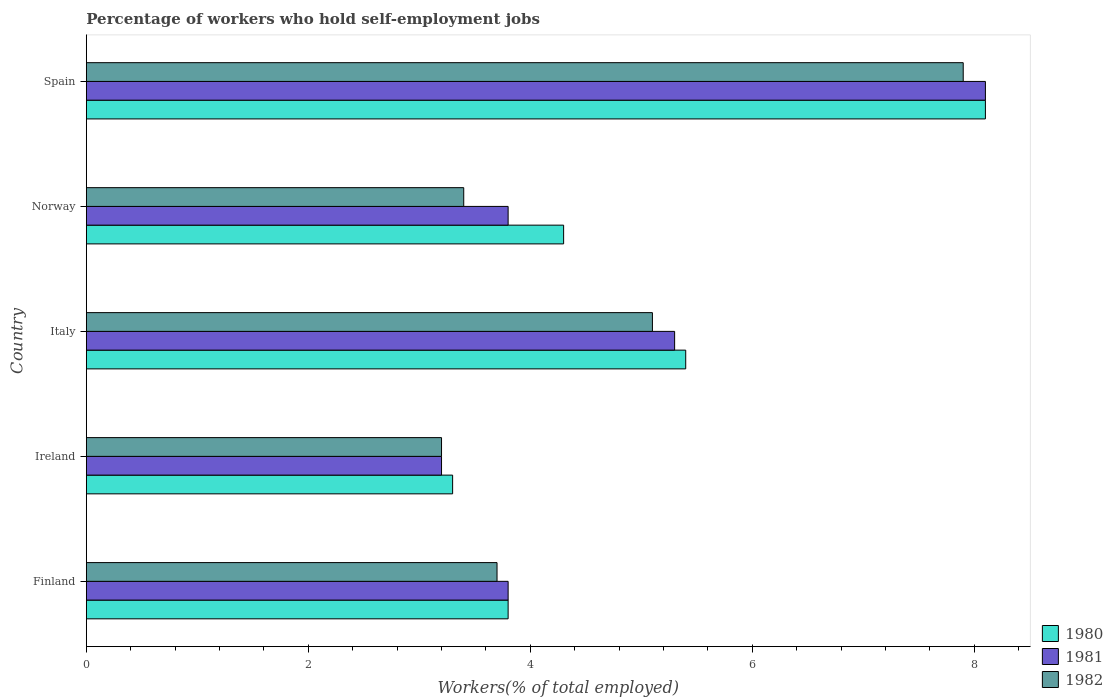How many bars are there on the 2nd tick from the top?
Offer a very short reply. 3. How many bars are there on the 3rd tick from the bottom?
Your response must be concise. 3. What is the label of the 4th group of bars from the top?
Your answer should be very brief. Ireland. In how many cases, is the number of bars for a given country not equal to the number of legend labels?
Your answer should be compact. 0. What is the percentage of self-employed workers in 1981 in Finland?
Ensure brevity in your answer.  3.8. Across all countries, what is the maximum percentage of self-employed workers in 1980?
Your answer should be compact. 8.1. Across all countries, what is the minimum percentage of self-employed workers in 1980?
Make the answer very short. 3.3. In which country was the percentage of self-employed workers in 1981 minimum?
Offer a terse response. Ireland. What is the total percentage of self-employed workers in 1982 in the graph?
Make the answer very short. 23.3. What is the difference between the percentage of self-employed workers in 1980 in Ireland and that in Italy?
Your answer should be compact. -2.1. What is the difference between the percentage of self-employed workers in 1981 in Italy and the percentage of self-employed workers in 1980 in Finland?
Ensure brevity in your answer.  1.5. What is the average percentage of self-employed workers in 1982 per country?
Give a very brief answer. 4.66. What is the difference between the percentage of self-employed workers in 1982 and percentage of self-employed workers in 1980 in Finland?
Your answer should be compact. -0.1. What is the ratio of the percentage of self-employed workers in 1981 in Finland to that in Spain?
Give a very brief answer. 0.47. Is the percentage of self-employed workers in 1982 in Ireland less than that in Norway?
Your answer should be very brief. Yes. What is the difference between the highest and the second highest percentage of self-employed workers in 1982?
Provide a short and direct response. 2.8. What is the difference between the highest and the lowest percentage of self-employed workers in 1981?
Give a very brief answer. 4.9. Is the sum of the percentage of self-employed workers in 1980 in Finland and Italy greater than the maximum percentage of self-employed workers in 1982 across all countries?
Your answer should be very brief. Yes. Is it the case that in every country, the sum of the percentage of self-employed workers in 1980 and percentage of self-employed workers in 1981 is greater than the percentage of self-employed workers in 1982?
Your answer should be compact. Yes. How many bars are there?
Ensure brevity in your answer.  15. Are all the bars in the graph horizontal?
Ensure brevity in your answer.  Yes. What is the difference between two consecutive major ticks on the X-axis?
Provide a succinct answer. 2. Are the values on the major ticks of X-axis written in scientific E-notation?
Provide a succinct answer. No. Does the graph contain grids?
Your answer should be compact. No. Where does the legend appear in the graph?
Make the answer very short. Bottom right. How many legend labels are there?
Make the answer very short. 3. How are the legend labels stacked?
Your response must be concise. Vertical. What is the title of the graph?
Offer a very short reply. Percentage of workers who hold self-employment jobs. What is the label or title of the X-axis?
Offer a terse response. Workers(% of total employed). What is the Workers(% of total employed) in 1980 in Finland?
Make the answer very short. 3.8. What is the Workers(% of total employed) in 1981 in Finland?
Offer a terse response. 3.8. What is the Workers(% of total employed) of 1982 in Finland?
Ensure brevity in your answer.  3.7. What is the Workers(% of total employed) in 1980 in Ireland?
Offer a very short reply. 3.3. What is the Workers(% of total employed) in 1981 in Ireland?
Your response must be concise. 3.2. What is the Workers(% of total employed) in 1982 in Ireland?
Provide a succinct answer. 3.2. What is the Workers(% of total employed) of 1980 in Italy?
Your response must be concise. 5.4. What is the Workers(% of total employed) in 1981 in Italy?
Provide a short and direct response. 5.3. What is the Workers(% of total employed) in 1982 in Italy?
Your response must be concise. 5.1. What is the Workers(% of total employed) of 1980 in Norway?
Provide a succinct answer. 4.3. What is the Workers(% of total employed) in 1981 in Norway?
Keep it short and to the point. 3.8. What is the Workers(% of total employed) of 1982 in Norway?
Provide a succinct answer. 3.4. What is the Workers(% of total employed) in 1980 in Spain?
Your answer should be very brief. 8.1. What is the Workers(% of total employed) in 1981 in Spain?
Provide a succinct answer. 8.1. What is the Workers(% of total employed) of 1982 in Spain?
Give a very brief answer. 7.9. Across all countries, what is the maximum Workers(% of total employed) in 1980?
Make the answer very short. 8.1. Across all countries, what is the maximum Workers(% of total employed) of 1981?
Make the answer very short. 8.1. Across all countries, what is the maximum Workers(% of total employed) of 1982?
Offer a terse response. 7.9. Across all countries, what is the minimum Workers(% of total employed) in 1980?
Offer a very short reply. 3.3. Across all countries, what is the minimum Workers(% of total employed) in 1981?
Offer a terse response. 3.2. Across all countries, what is the minimum Workers(% of total employed) of 1982?
Provide a short and direct response. 3.2. What is the total Workers(% of total employed) of 1980 in the graph?
Your answer should be compact. 24.9. What is the total Workers(% of total employed) of 1981 in the graph?
Keep it short and to the point. 24.2. What is the total Workers(% of total employed) in 1982 in the graph?
Provide a succinct answer. 23.3. What is the difference between the Workers(% of total employed) in 1980 in Finland and that in Italy?
Your answer should be very brief. -1.6. What is the difference between the Workers(% of total employed) of 1982 in Finland and that in Italy?
Your answer should be compact. -1.4. What is the difference between the Workers(% of total employed) of 1980 in Finland and that in Norway?
Provide a short and direct response. -0.5. What is the difference between the Workers(% of total employed) in 1981 in Finland and that in Norway?
Make the answer very short. 0. What is the difference between the Workers(% of total employed) of 1980 in Ireland and that in Italy?
Offer a very short reply. -2.1. What is the difference between the Workers(% of total employed) of 1981 in Ireland and that in Italy?
Offer a terse response. -2.1. What is the difference between the Workers(% of total employed) of 1980 in Ireland and that in Norway?
Your answer should be compact. -1. What is the difference between the Workers(% of total employed) in 1980 in Ireland and that in Spain?
Your answer should be compact. -4.8. What is the difference between the Workers(% of total employed) of 1981 in Ireland and that in Spain?
Give a very brief answer. -4.9. What is the difference between the Workers(% of total employed) of 1980 in Italy and that in Norway?
Keep it short and to the point. 1.1. What is the difference between the Workers(% of total employed) in 1981 in Italy and that in Norway?
Offer a terse response. 1.5. What is the difference between the Workers(% of total employed) in 1980 in Italy and that in Spain?
Offer a very short reply. -2.7. What is the difference between the Workers(% of total employed) in 1981 in Italy and that in Spain?
Ensure brevity in your answer.  -2.8. What is the difference between the Workers(% of total employed) in 1982 in Italy and that in Spain?
Keep it short and to the point. -2.8. What is the difference between the Workers(% of total employed) of 1982 in Norway and that in Spain?
Your response must be concise. -4.5. What is the difference between the Workers(% of total employed) of 1981 in Finland and the Workers(% of total employed) of 1982 in Ireland?
Your answer should be very brief. 0.6. What is the difference between the Workers(% of total employed) in 1980 in Finland and the Workers(% of total employed) in 1981 in Italy?
Keep it short and to the point. -1.5. What is the difference between the Workers(% of total employed) of 1981 in Finland and the Workers(% of total employed) of 1982 in Italy?
Keep it short and to the point. -1.3. What is the difference between the Workers(% of total employed) in 1980 in Finland and the Workers(% of total employed) in 1981 in Norway?
Ensure brevity in your answer.  0. What is the difference between the Workers(% of total employed) in 1980 in Finland and the Workers(% of total employed) in 1982 in Norway?
Your answer should be very brief. 0.4. What is the difference between the Workers(% of total employed) of 1981 in Finland and the Workers(% of total employed) of 1982 in Norway?
Keep it short and to the point. 0.4. What is the difference between the Workers(% of total employed) in 1980 in Finland and the Workers(% of total employed) in 1981 in Spain?
Offer a terse response. -4.3. What is the difference between the Workers(% of total employed) in 1981 in Ireland and the Workers(% of total employed) in 1982 in Italy?
Offer a terse response. -1.9. What is the difference between the Workers(% of total employed) in 1980 in Ireland and the Workers(% of total employed) in 1982 in Spain?
Your response must be concise. -4.6. What is the difference between the Workers(% of total employed) in 1981 in Ireland and the Workers(% of total employed) in 1982 in Spain?
Make the answer very short. -4.7. What is the difference between the Workers(% of total employed) of 1980 in Italy and the Workers(% of total employed) of 1981 in Norway?
Your answer should be very brief. 1.6. What is the difference between the Workers(% of total employed) of 1980 in Italy and the Workers(% of total employed) of 1982 in Norway?
Your answer should be very brief. 2. What is the difference between the Workers(% of total employed) of 1981 in Italy and the Workers(% of total employed) of 1982 in Spain?
Provide a short and direct response. -2.6. What is the difference between the Workers(% of total employed) in 1980 in Norway and the Workers(% of total employed) in 1982 in Spain?
Offer a very short reply. -3.6. What is the difference between the Workers(% of total employed) of 1981 in Norway and the Workers(% of total employed) of 1982 in Spain?
Your answer should be compact. -4.1. What is the average Workers(% of total employed) in 1980 per country?
Provide a succinct answer. 4.98. What is the average Workers(% of total employed) of 1981 per country?
Offer a very short reply. 4.84. What is the average Workers(% of total employed) of 1982 per country?
Your answer should be very brief. 4.66. What is the difference between the Workers(% of total employed) in 1980 and Workers(% of total employed) in 1981 in Finland?
Provide a succinct answer. 0. What is the difference between the Workers(% of total employed) of 1981 and Workers(% of total employed) of 1982 in Finland?
Your response must be concise. 0.1. What is the difference between the Workers(% of total employed) of 1981 and Workers(% of total employed) of 1982 in Ireland?
Provide a short and direct response. 0. What is the difference between the Workers(% of total employed) in 1981 and Workers(% of total employed) in 1982 in Italy?
Give a very brief answer. 0.2. What is the difference between the Workers(% of total employed) of 1980 and Workers(% of total employed) of 1981 in Norway?
Keep it short and to the point. 0.5. What is the difference between the Workers(% of total employed) of 1980 and Workers(% of total employed) of 1982 in Norway?
Provide a succinct answer. 0.9. What is the difference between the Workers(% of total employed) of 1981 and Workers(% of total employed) of 1982 in Norway?
Keep it short and to the point. 0.4. What is the difference between the Workers(% of total employed) of 1980 and Workers(% of total employed) of 1981 in Spain?
Your response must be concise. 0. What is the ratio of the Workers(% of total employed) of 1980 in Finland to that in Ireland?
Your answer should be very brief. 1.15. What is the ratio of the Workers(% of total employed) in 1981 in Finland to that in Ireland?
Keep it short and to the point. 1.19. What is the ratio of the Workers(% of total employed) of 1982 in Finland to that in Ireland?
Offer a terse response. 1.16. What is the ratio of the Workers(% of total employed) of 1980 in Finland to that in Italy?
Make the answer very short. 0.7. What is the ratio of the Workers(% of total employed) of 1981 in Finland to that in Italy?
Keep it short and to the point. 0.72. What is the ratio of the Workers(% of total employed) of 1982 in Finland to that in Italy?
Provide a short and direct response. 0.73. What is the ratio of the Workers(% of total employed) of 1980 in Finland to that in Norway?
Your response must be concise. 0.88. What is the ratio of the Workers(% of total employed) in 1981 in Finland to that in Norway?
Your answer should be compact. 1. What is the ratio of the Workers(% of total employed) of 1982 in Finland to that in Norway?
Give a very brief answer. 1.09. What is the ratio of the Workers(% of total employed) in 1980 in Finland to that in Spain?
Make the answer very short. 0.47. What is the ratio of the Workers(% of total employed) in 1981 in Finland to that in Spain?
Provide a succinct answer. 0.47. What is the ratio of the Workers(% of total employed) of 1982 in Finland to that in Spain?
Provide a succinct answer. 0.47. What is the ratio of the Workers(% of total employed) of 1980 in Ireland to that in Italy?
Your answer should be very brief. 0.61. What is the ratio of the Workers(% of total employed) of 1981 in Ireland to that in Italy?
Your answer should be compact. 0.6. What is the ratio of the Workers(% of total employed) of 1982 in Ireland to that in Italy?
Your answer should be compact. 0.63. What is the ratio of the Workers(% of total employed) in 1980 in Ireland to that in Norway?
Provide a short and direct response. 0.77. What is the ratio of the Workers(% of total employed) in 1981 in Ireland to that in Norway?
Provide a short and direct response. 0.84. What is the ratio of the Workers(% of total employed) of 1982 in Ireland to that in Norway?
Give a very brief answer. 0.94. What is the ratio of the Workers(% of total employed) of 1980 in Ireland to that in Spain?
Offer a very short reply. 0.41. What is the ratio of the Workers(% of total employed) of 1981 in Ireland to that in Spain?
Your answer should be very brief. 0.4. What is the ratio of the Workers(% of total employed) in 1982 in Ireland to that in Spain?
Offer a very short reply. 0.41. What is the ratio of the Workers(% of total employed) of 1980 in Italy to that in Norway?
Provide a succinct answer. 1.26. What is the ratio of the Workers(% of total employed) in 1981 in Italy to that in Norway?
Offer a very short reply. 1.39. What is the ratio of the Workers(% of total employed) in 1982 in Italy to that in Norway?
Keep it short and to the point. 1.5. What is the ratio of the Workers(% of total employed) of 1980 in Italy to that in Spain?
Provide a short and direct response. 0.67. What is the ratio of the Workers(% of total employed) of 1981 in Italy to that in Spain?
Your response must be concise. 0.65. What is the ratio of the Workers(% of total employed) in 1982 in Italy to that in Spain?
Your answer should be compact. 0.65. What is the ratio of the Workers(% of total employed) in 1980 in Norway to that in Spain?
Your response must be concise. 0.53. What is the ratio of the Workers(% of total employed) in 1981 in Norway to that in Spain?
Your response must be concise. 0.47. What is the ratio of the Workers(% of total employed) of 1982 in Norway to that in Spain?
Provide a succinct answer. 0.43. What is the difference between the highest and the second highest Workers(% of total employed) of 1981?
Keep it short and to the point. 2.8. What is the difference between the highest and the second highest Workers(% of total employed) of 1982?
Offer a very short reply. 2.8. What is the difference between the highest and the lowest Workers(% of total employed) in 1980?
Give a very brief answer. 4.8. What is the difference between the highest and the lowest Workers(% of total employed) in 1982?
Your answer should be compact. 4.7. 